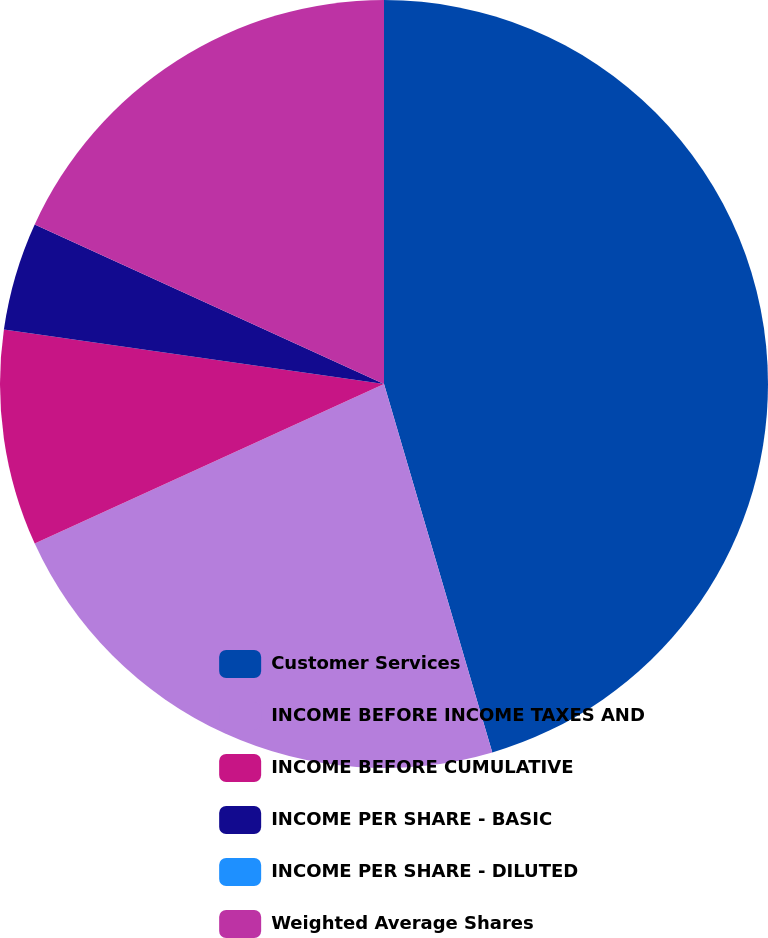Convert chart. <chart><loc_0><loc_0><loc_500><loc_500><pie_chart><fcel>Customer Services<fcel>INCOME BEFORE INCOME TAXES AND<fcel>INCOME BEFORE CUMULATIVE<fcel>INCOME PER SHARE - BASIC<fcel>INCOME PER SHARE - DILUTED<fcel>Weighted Average Shares<nl><fcel>45.45%<fcel>22.73%<fcel>9.09%<fcel>4.55%<fcel>0.0%<fcel>18.18%<nl></chart> 